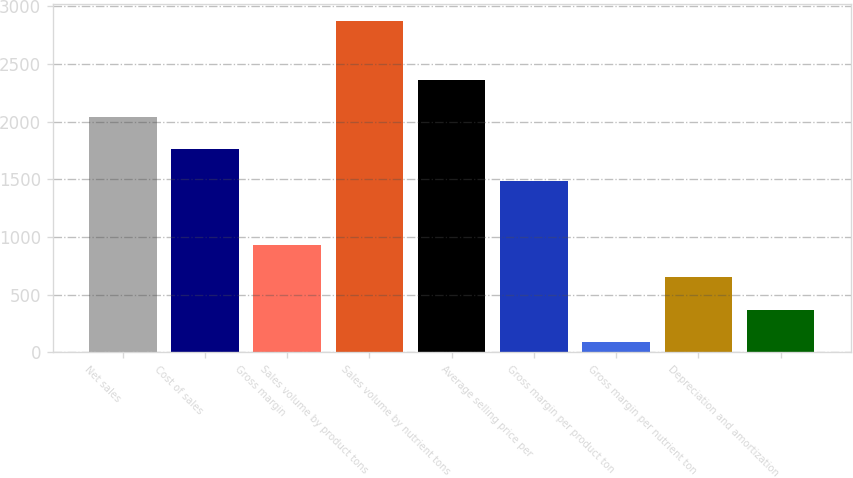<chart> <loc_0><loc_0><loc_500><loc_500><bar_chart><fcel>Net sales<fcel>Cost of sales<fcel>Gross margin<fcel>Sales volume by product tons<fcel>Sales volume by nutrient tons<fcel>Average selling price per<fcel>Gross margin per product ton<fcel>Gross margin per nutrient ton<fcel>Depreciation and amortization<nl><fcel>2039.7<fcel>1761.6<fcel>927.3<fcel>2874<fcel>2358<fcel>1483.5<fcel>93<fcel>649.2<fcel>371.1<nl></chart> 